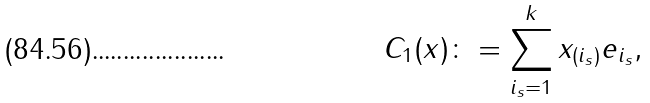<formula> <loc_0><loc_0><loc_500><loc_500>C _ { 1 } ( x ) \colon = \sum _ { i _ { s } = 1 } ^ { k } x _ { ( i _ { s } ) } e _ { i _ { s } } ,</formula> 